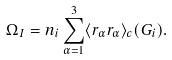Convert formula to latex. <formula><loc_0><loc_0><loc_500><loc_500>\Omega _ { I } = n _ { i } \sum _ { \alpha = 1 } ^ { 3 } \langle r _ { \alpha } r _ { \alpha } \rangle _ { c } ( G _ { i } ) .</formula> 